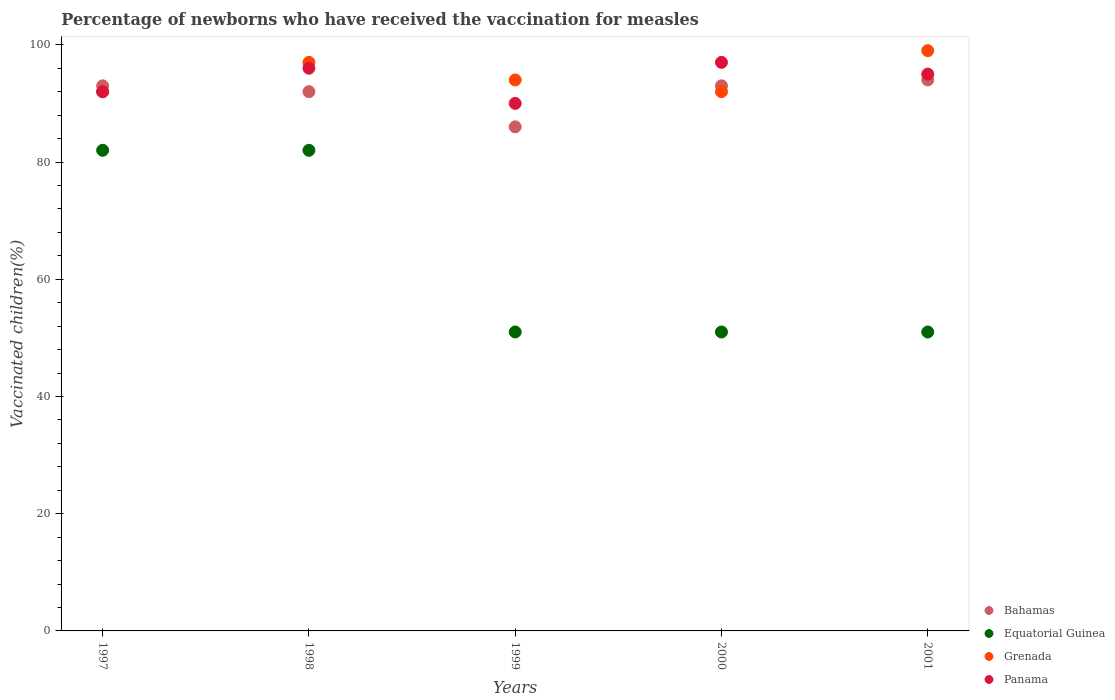How many different coloured dotlines are there?
Ensure brevity in your answer.  4. Is the number of dotlines equal to the number of legend labels?
Keep it short and to the point. Yes. What is the percentage of vaccinated children in Grenada in 2001?
Provide a succinct answer. 99. Across all years, what is the maximum percentage of vaccinated children in Panama?
Make the answer very short. 97. Across all years, what is the minimum percentage of vaccinated children in Panama?
Keep it short and to the point. 90. In which year was the percentage of vaccinated children in Equatorial Guinea maximum?
Your answer should be compact. 1997. In which year was the percentage of vaccinated children in Panama minimum?
Provide a succinct answer. 1999. What is the total percentage of vaccinated children in Bahamas in the graph?
Offer a terse response. 458. What is the difference between the percentage of vaccinated children in Equatorial Guinea in 1997 and that in 1999?
Ensure brevity in your answer.  31. What is the difference between the percentage of vaccinated children in Grenada in 2001 and the percentage of vaccinated children in Panama in 2000?
Make the answer very short. 2. What is the average percentage of vaccinated children in Bahamas per year?
Your response must be concise. 91.6. What is the ratio of the percentage of vaccinated children in Grenada in 1998 to that in 1999?
Make the answer very short. 1.03. Is the percentage of vaccinated children in Equatorial Guinea in 1997 less than that in 1998?
Offer a terse response. No. In how many years, is the percentage of vaccinated children in Panama greater than the average percentage of vaccinated children in Panama taken over all years?
Your answer should be compact. 3. Is the sum of the percentage of vaccinated children in Panama in 1997 and 1999 greater than the maximum percentage of vaccinated children in Equatorial Guinea across all years?
Make the answer very short. Yes. Is it the case that in every year, the sum of the percentage of vaccinated children in Equatorial Guinea and percentage of vaccinated children in Panama  is greater than the sum of percentage of vaccinated children in Grenada and percentage of vaccinated children in Bahamas?
Keep it short and to the point. No. Is the percentage of vaccinated children in Equatorial Guinea strictly greater than the percentage of vaccinated children in Bahamas over the years?
Keep it short and to the point. No. How many dotlines are there?
Make the answer very short. 4. How many years are there in the graph?
Provide a short and direct response. 5. Are the values on the major ticks of Y-axis written in scientific E-notation?
Your response must be concise. No. Does the graph contain any zero values?
Make the answer very short. No. Where does the legend appear in the graph?
Provide a short and direct response. Bottom right. How are the legend labels stacked?
Your response must be concise. Vertical. What is the title of the graph?
Your answer should be compact. Percentage of newborns who have received the vaccination for measles. What is the label or title of the Y-axis?
Provide a succinct answer. Vaccinated children(%). What is the Vaccinated children(%) of Bahamas in 1997?
Keep it short and to the point. 93. What is the Vaccinated children(%) in Grenada in 1997?
Provide a succinct answer. 92. What is the Vaccinated children(%) of Panama in 1997?
Provide a short and direct response. 92. What is the Vaccinated children(%) in Bahamas in 1998?
Provide a succinct answer. 92. What is the Vaccinated children(%) in Grenada in 1998?
Give a very brief answer. 97. What is the Vaccinated children(%) in Panama in 1998?
Give a very brief answer. 96. What is the Vaccinated children(%) in Equatorial Guinea in 1999?
Provide a succinct answer. 51. What is the Vaccinated children(%) of Grenada in 1999?
Provide a succinct answer. 94. What is the Vaccinated children(%) in Panama in 1999?
Provide a short and direct response. 90. What is the Vaccinated children(%) in Bahamas in 2000?
Offer a terse response. 93. What is the Vaccinated children(%) in Grenada in 2000?
Ensure brevity in your answer.  92. What is the Vaccinated children(%) in Panama in 2000?
Provide a succinct answer. 97. What is the Vaccinated children(%) of Bahamas in 2001?
Make the answer very short. 94. What is the Vaccinated children(%) of Grenada in 2001?
Keep it short and to the point. 99. What is the Vaccinated children(%) in Panama in 2001?
Your answer should be compact. 95. Across all years, what is the maximum Vaccinated children(%) in Bahamas?
Offer a terse response. 94. Across all years, what is the maximum Vaccinated children(%) of Panama?
Make the answer very short. 97. Across all years, what is the minimum Vaccinated children(%) in Grenada?
Offer a very short reply. 92. Across all years, what is the minimum Vaccinated children(%) of Panama?
Offer a terse response. 90. What is the total Vaccinated children(%) in Bahamas in the graph?
Ensure brevity in your answer.  458. What is the total Vaccinated children(%) in Equatorial Guinea in the graph?
Offer a terse response. 317. What is the total Vaccinated children(%) of Grenada in the graph?
Offer a terse response. 474. What is the total Vaccinated children(%) of Panama in the graph?
Your response must be concise. 470. What is the difference between the Vaccinated children(%) in Equatorial Guinea in 1997 and that in 1998?
Provide a succinct answer. 0. What is the difference between the Vaccinated children(%) of Grenada in 1997 and that in 1998?
Make the answer very short. -5. What is the difference between the Vaccinated children(%) of Grenada in 1997 and that in 1999?
Offer a very short reply. -2. What is the difference between the Vaccinated children(%) of Panama in 1997 and that in 2000?
Offer a very short reply. -5. What is the difference between the Vaccinated children(%) in Grenada in 1997 and that in 2001?
Provide a short and direct response. -7. What is the difference between the Vaccinated children(%) in Panama in 1997 and that in 2001?
Your answer should be very brief. -3. What is the difference between the Vaccinated children(%) in Bahamas in 1998 and that in 1999?
Keep it short and to the point. 6. What is the difference between the Vaccinated children(%) in Equatorial Guinea in 1998 and that in 1999?
Offer a very short reply. 31. What is the difference between the Vaccinated children(%) of Bahamas in 1998 and that in 2000?
Provide a succinct answer. -1. What is the difference between the Vaccinated children(%) in Equatorial Guinea in 1998 and that in 2000?
Offer a terse response. 31. What is the difference between the Vaccinated children(%) of Grenada in 1998 and that in 2000?
Provide a succinct answer. 5. What is the difference between the Vaccinated children(%) of Panama in 1998 and that in 2000?
Ensure brevity in your answer.  -1. What is the difference between the Vaccinated children(%) in Bahamas in 1998 and that in 2001?
Provide a short and direct response. -2. What is the difference between the Vaccinated children(%) of Bahamas in 1999 and that in 2000?
Keep it short and to the point. -7. What is the difference between the Vaccinated children(%) of Bahamas in 1999 and that in 2001?
Give a very brief answer. -8. What is the difference between the Vaccinated children(%) in Panama in 1999 and that in 2001?
Your response must be concise. -5. What is the difference between the Vaccinated children(%) in Equatorial Guinea in 2000 and that in 2001?
Offer a very short reply. 0. What is the difference between the Vaccinated children(%) of Bahamas in 1997 and the Vaccinated children(%) of Grenada in 1998?
Offer a terse response. -4. What is the difference between the Vaccinated children(%) of Equatorial Guinea in 1997 and the Vaccinated children(%) of Grenada in 1998?
Your answer should be compact. -15. What is the difference between the Vaccinated children(%) in Equatorial Guinea in 1997 and the Vaccinated children(%) in Panama in 1998?
Your answer should be very brief. -14. What is the difference between the Vaccinated children(%) of Bahamas in 1997 and the Vaccinated children(%) of Grenada in 1999?
Your response must be concise. -1. What is the difference between the Vaccinated children(%) of Bahamas in 1997 and the Vaccinated children(%) of Panama in 1999?
Provide a short and direct response. 3. What is the difference between the Vaccinated children(%) of Equatorial Guinea in 1997 and the Vaccinated children(%) of Panama in 1999?
Make the answer very short. -8. What is the difference between the Vaccinated children(%) of Equatorial Guinea in 1997 and the Vaccinated children(%) of Grenada in 2000?
Your response must be concise. -10. What is the difference between the Vaccinated children(%) of Equatorial Guinea in 1997 and the Vaccinated children(%) of Panama in 2000?
Your response must be concise. -15. What is the difference between the Vaccinated children(%) of Bahamas in 1997 and the Vaccinated children(%) of Equatorial Guinea in 2001?
Your response must be concise. 42. What is the difference between the Vaccinated children(%) of Bahamas in 1997 and the Vaccinated children(%) of Panama in 2001?
Your answer should be very brief. -2. What is the difference between the Vaccinated children(%) of Equatorial Guinea in 1997 and the Vaccinated children(%) of Panama in 2001?
Your response must be concise. -13. What is the difference between the Vaccinated children(%) in Equatorial Guinea in 1998 and the Vaccinated children(%) in Grenada in 1999?
Keep it short and to the point. -12. What is the difference between the Vaccinated children(%) in Equatorial Guinea in 1998 and the Vaccinated children(%) in Panama in 1999?
Offer a terse response. -8. What is the difference between the Vaccinated children(%) of Grenada in 1998 and the Vaccinated children(%) of Panama in 1999?
Ensure brevity in your answer.  7. What is the difference between the Vaccinated children(%) of Bahamas in 1998 and the Vaccinated children(%) of Equatorial Guinea in 2000?
Ensure brevity in your answer.  41. What is the difference between the Vaccinated children(%) of Equatorial Guinea in 1998 and the Vaccinated children(%) of Grenada in 2000?
Your answer should be compact. -10. What is the difference between the Vaccinated children(%) of Equatorial Guinea in 1998 and the Vaccinated children(%) of Panama in 2000?
Keep it short and to the point. -15. What is the difference between the Vaccinated children(%) in Bahamas in 1998 and the Vaccinated children(%) in Equatorial Guinea in 2001?
Keep it short and to the point. 41. What is the difference between the Vaccinated children(%) of Equatorial Guinea in 1998 and the Vaccinated children(%) of Grenada in 2001?
Offer a terse response. -17. What is the difference between the Vaccinated children(%) of Equatorial Guinea in 1998 and the Vaccinated children(%) of Panama in 2001?
Your response must be concise. -13. What is the difference between the Vaccinated children(%) in Grenada in 1998 and the Vaccinated children(%) in Panama in 2001?
Your answer should be compact. 2. What is the difference between the Vaccinated children(%) of Bahamas in 1999 and the Vaccinated children(%) of Equatorial Guinea in 2000?
Your answer should be compact. 35. What is the difference between the Vaccinated children(%) of Bahamas in 1999 and the Vaccinated children(%) of Grenada in 2000?
Offer a very short reply. -6. What is the difference between the Vaccinated children(%) of Equatorial Guinea in 1999 and the Vaccinated children(%) of Grenada in 2000?
Ensure brevity in your answer.  -41. What is the difference between the Vaccinated children(%) of Equatorial Guinea in 1999 and the Vaccinated children(%) of Panama in 2000?
Your answer should be very brief. -46. What is the difference between the Vaccinated children(%) in Grenada in 1999 and the Vaccinated children(%) in Panama in 2000?
Offer a terse response. -3. What is the difference between the Vaccinated children(%) of Bahamas in 1999 and the Vaccinated children(%) of Grenada in 2001?
Give a very brief answer. -13. What is the difference between the Vaccinated children(%) of Bahamas in 1999 and the Vaccinated children(%) of Panama in 2001?
Your answer should be compact. -9. What is the difference between the Vaccinated children(%) of Equatorial Guinea in 1999 and the Vaccinated children(%) of Grenada in 2001?
Your answer should be compact. -48. What is the difference between the Vaccinated children(%) of Equatorial Guinea in 1999 and the Vaccinated children(%) of Panama in 2001?
Provide a short and direct response. -44. What is the difference between the Vaccinated children(%) of Grenada in 1999 and the Vaccinated children(%) of Panama in 2001?
Your response must be concise. -1. What is the difference between the Vaccinated children(%) in Bahamas in 2000 and the Vaccinated children(%) in Equatorial Guinea in 2001?
Offer a very short reply. 42. What is the difference between the Vaccinated children(%) of Equatorial Guinea in 2000 and the Vaccinated children(%) of Grenada in 2001?
Offer a very short reply. -48. What is the difference between the Vaccinated children(%) in Equatorial Guinea in 2000 and the Vaccinated children(%) in Panama in 2001?
Give a very brief answer. -44. What is the difference between the Vaccinated children(%) in Grenada in 2000 and the Vaccinated children(%) in Panama in 2001?
Make the answer very short. -3. What is the average Vaccinated children(%) of Bahamas per year?
Offer a very short reply. 91.6. What is the average Vaccinated children(%) in Equatorial Guinea per year?
Ensure brevity in your answer.  63.4. What is the average Vaccinated children(%) in Grenada per year?
Your answer should be very brief. 94.8. What is the average Vaccinated children(%) of Panama per year?
Ensure brevity in your answer.  94. In the year 1997, what is the difference between the Vaccinated children(%) of Bahamas and Vaccinated children(%) of Equatorial Guinea?
Provide a short and direct response. 11. In the year 1997, what is the difference between the Vaccinated children(%) in Bahamas and Vaccinated children(%) in Grenada?
Your answer should be very brief. 1. In the year 1997, what is the difference between the Vaccinated children(%) in Grenada and Vaccinated children(%) in Panama?
Ensure brevity in your answer.  0. In the year 1998, what is the difference between the Vaccinated children(%) of Bahamas and Vaccinated children(%) of Grenada?
Ensure brevity in your answer.  -5. In the year 1999, what is the difference between the Vaccinated children(%) of Bahamas and Vaccinated children(%) of Grenada?
Provide a short and direct response. -8. In the year 1999, what is the difference between the Vaccinated children(%) of Equatorial Guinea and Vaccinated children(%) of Grenada?
Provide a short and direct response. -43. In the year 1999, what is the difference between the Vaccinated children(%) of Equatorial Guinea and Vaccinated children(%) of Panama?
Make the answer very short. -39. In the year 2000, what is the difference between the Vaccinated children(%) in Bahamas and Vaccinated children(%) in Equatorial Guinea?
Provide a short and direct response. 42. In the year 2000, what is the difference between the Vaccinated children(%) of Equatorial Guinea and Vaccinated children(%) of Grenada?
Keep it short and to the point. -41. In the year 2000, what is the difference between the Vaccinated children(%) of Equatorial Guinea and Vaccinated children(%) of Panama?
Keep it short and to the point. -46. In the year 2001, what is the difference between the Vaccinated children(%) in Bahamas and Vaccinated children(%) in Equatorial Guinea?
Offer a terse response. 43. In the year 2001, what is the difference between the Vaccinated children(%) in Equatorial Guinea and Vaccinated children(%) in Grenada?
Offer a very short reply. -48. In the year 2001, what is the difference between the Vaccinated children(%) of Equatorial Guinea and Vaccinated children(%) of Panama?
Offer a very short reply. -44. What is the ratio of the Vaccinated children(%) of Bahamas in 1997 to that in 1998?
Give a very brief answer. 1.01. What is the ratio of the Vaccinated children(%) in Grenada in 1997 to that in 1998?
Your answer should be very brief. 0.95. What is the ratio of the Vaccinated children(%) of Bahamas in 1997 to that in 1999?
Your response must be concise. 1.08. What is the ratio of the Vaccinated children(%) in Equatorial Guinea in 1997 to that in 1999?
Offer a terse response. 1.61. What is the ratio of the Vaccinated children(%) of Grenada in 1997 to that in 1999?
Give a very brief answer. 0.98. What is the ratio of the Vaccinated children(%) in Panama in 1997 to that in 1999?
Provide a short and direct response. 1.02. What is the ratio of the Vaccinated children(%) of Equatorial Guinea in 1997 to that in 2000?
Give a very brief answer. 1.61. What is the ratio of the Vaccinated children(%) of Grenada in 1997 to that in 2000?
Provide a short and direct response. 1. What is the ratio of the Vaccinated children(%) in Panama in 1997 to that in 2000?
Your answer should be compact. 0.95. What is the ratio of the Vaccinated children(%) in Bahamas in 1997 to that in 2001?
Ensure brevity in your answer.  0.99. What is the ratio of the Vaccinated children(%) in Equatorial Guinea in 1997 to that in 2001?
Your response must be concise. 1.61. What is the ratio of the Vaccinated children(%) in Grenada in 1997 to that in 2001?
Keep it short and to the point. 0.93. What is the ratio of the Vaccinated children(%) of Panama in 1997 to that in 2001?
Make the answer very short. 0.97. What is the ratio of the Vaccinated children(%) of Bahamas in 1998 to that in 1999?
Your answer should be very brief. 1.07. What is the ratio of the Vaccinated children(%) of Equatorial Guinea in 1998 to that in 1999?
Your response must be concise. 1.61. What is the ratio of the Vaccinated children(%) of Grenada in 1998 to that in 1999?
Your answer should be very brief. 1.03. What is the ratio of the Vaccinated children(%) in Panama in 1998 to that in 1999?
Offer a very short reply. 1.07. What is the ratio of the Vaccinated children(%) of Equatorial Guinea in 1998 to that in 2000?
Keep it short and to the point. 1.61. What is the ratio of the Vaccinated children(%) in Grenada in 1998 to that in 2000?
Ensure brevity in your answer.  1.05. What is the ratio of the Vaccinated children(%) in Panama in 1998 to that in 2000?
Offer a very short reply. 0.99. What is the ratio of the Vaccinated children(%) in Bahamas in 1998 to that in 2001?
Your answer should be very brief. 0.98. What is the ratio of the Vaccinated children(%) in Equatorial Guinea in 1998 to that in 2001?
Offer a very short reply. 1.61. What is the ratio of the Vaccinated children(%) in Grenada in 1998 to that in 2001?
Offer a very short reply. 0.98. What is the ratio of the Vaccinated children(%) of Panama in 1998 to that in 2001?
Offer a very short reply. 1.01. What is the ratio of the Vaccinated children(%) of Bahamas in 1999 to that in 2000?
Give a very brief answer. 0.92. What is the ratio of the Vaccinated children(%) of Equatorial Guinea in 1999 to that in 2000?
Provide a short and direct response. 1. What is the ratio of the Vaccinated children(%) in Grenada in 1999 to that in 2000?
Offer a very short reply. 1.02. What is the ratio of the Vaccinated children(%) of Panama in 1999 to that in 2000?
Offer a terse response. 0.93. What is the ratio of the Vaccinated children(%) in Bahamas in 1999 to that in 2001?
Provide a short and direct response. 0.91. What is the ratio of the Vaccinated children(%) in Equatorial Guinea in 1999 to that in 2001?
Your answer should be very brief. 1. What is the ratio of the Vaccinated children(%) in Grenada in 1999 to that in 2001?
Give a very brief answer. 0.95. What is the ratio of the Vaccinated children(%) of Panama in 1999 to that in 2001?
Provide a short and direct response. 0.95. What is the ratio of the Vaccinated children(%) of Bahamas in 2000 to that in 2001?
Give a very brief answer. 0.99. What is the ratio of the Vaccinated children(%) in Grenada in 2000 to that in 2001?
Offer a very short reply. 0.93. What is the ratio of the Vaccinated children(%) in Panama in 2000 to that in 2001?
Provide a succinct answer. 1.02. What is the difference between the highest and the second highest Vaccinated children(%) of Equatorial Guinea?
Your answer should be very brief. 0. What is the difference between the highest and the second highest Vaccinated children(%) of Grenada?
Ensure brevity in your answer.  2. What is the difference between the highest and the second highest Vaccinated children(%) in Panama?
Your answer should be compact. 1. What is the difference between the highest and the lowest Vaccinated children(%) in Bahamas?
Ensure brevity in your answer.  8. 